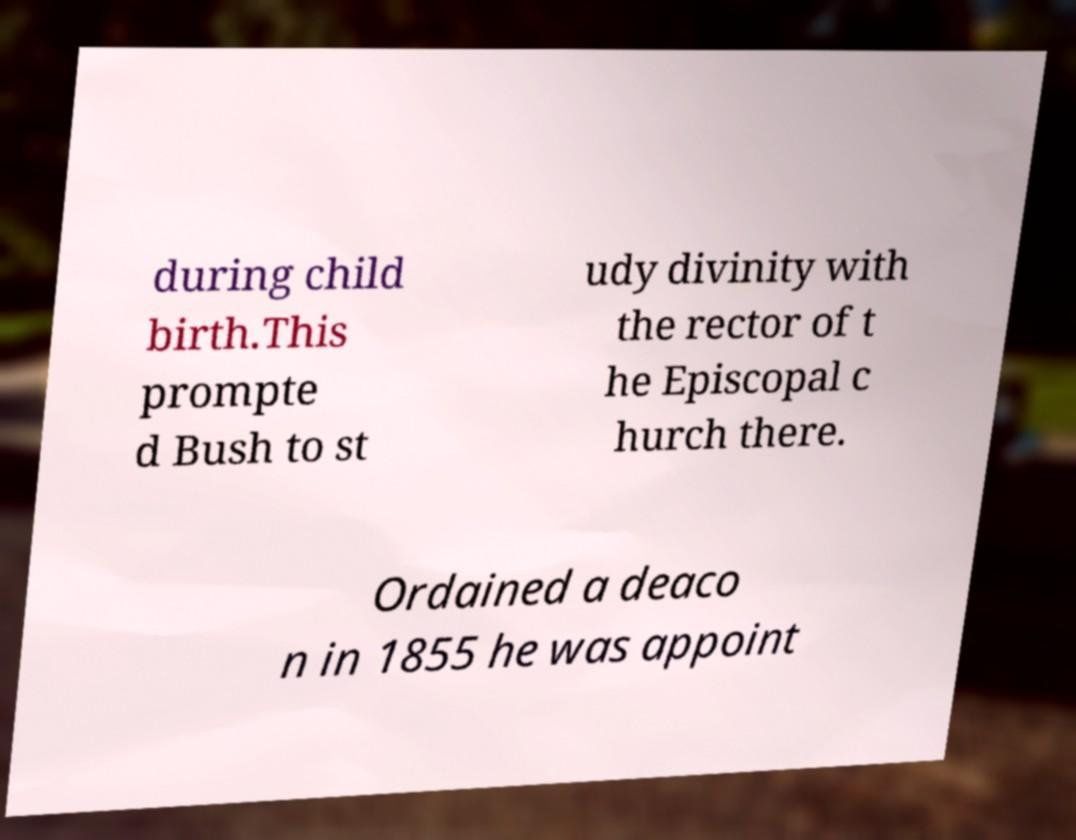For documentation purposes, I need the text within this image transcribed. Could you provide that? during child birth.This prompte d Bush to st udy divinity with the rector of t he Episcopal c hurch there. Ordained a deaco n in 1855 he was appoint 